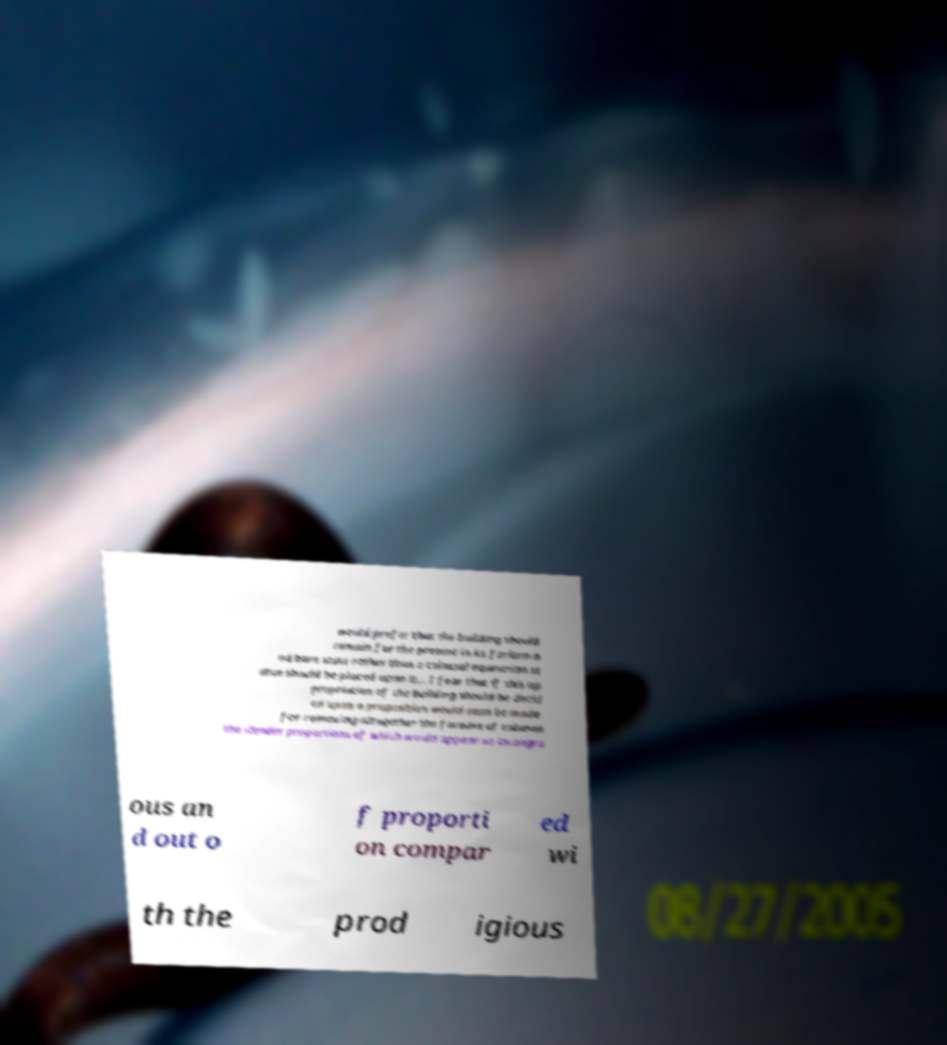Please read and relay the text visible in this image. What does it say? would prefer that the building should remain for the present in its forlorn a nd bare state rather than a colossal equestrian st atue should be placed upon it... I fear that if this ap propriation of the building should be decid ed upon a proposition would soon be made for removing altogether the facades of columns the slender proportions of which would appear so incongru ous an d out o f proporti on compar ed wi th the prod igious 